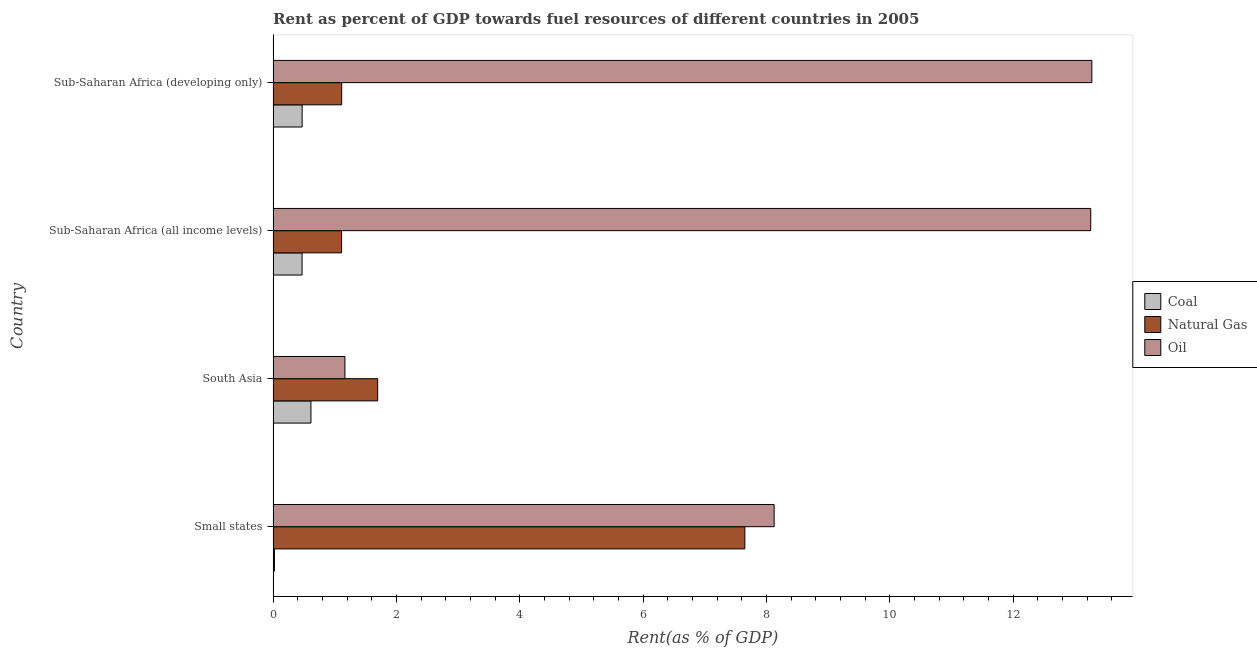How many different coloured bars are there?
Your response must be concise. 3. How many groups of bars are there?
Provide a succinct answer. 4. Are the number of bars per tick equal to the number of legend labels?
Your response must be concise. Yes. Are the number of bars on each tick of the Y-axis equal?
Give a very brief answer. Yes. How many bars are there on the 2nd tick from the top?
Ensure brevity in your answer.  3. How many bars are there on the 4th tick from the bottom?
Keep it short and to the point. 3. What is the label of the 1st group of bars from the top?
Offer a very short reply. Sub-Saharan Africa (developing only). What is the rent towards coal in Small states?
Offer a terse response. 0.02. Across all countries, what is the maximum rent towards coal?
Keep it short and to the point. 0.61. Across all countries, what is the minimum rent towards coal?
Your answer should be compact. 0.02. In which country was the rent towards oil maximum?
Provide a succinct answer. Sub-Saharan Africa (developing only). What is the total rent towards oil in the graph?
Make the answer very short. 35.83. What is the difference between the rent towards natural gas in South Asia and that in Sub-Saharan Africa (developing only)?
Your answer should be very brief. 0.58. What is the difference between the rent towards oil in Small states and the rent towards natural gas in Sub-Saharan Africa (developing only)?
Offer a terse response. 7.01. What is the average rent towards oil per country?
Keep it short and to the point. 8.96. What is the difference between the rent towards oil and rent towards natural gas in Small states?
Provide a short and direct response. 0.47. What is the ratio of the rent towards oil in South Asia to that in Sub-Saharan Africa (all income levels)?
Provide a short and direct response. 0.09. What is the difference between the highest and the second highest rent towards coal?
Provide a short and direct response. 0.14. What is the difference between the highest and the lowest rent towards oil?
Offer a terse response. 12.11. In how many countries, is the rent towards oil greater than the average rent towards oil taken over all countries?
Offer a very short reply. 2. Is the sum of the rent towards natural gas in South Asia and Sub-Saharan Africa (developing only) greater than the maximum rent towards coal across all countries?
Make the answer very short. Yes. What does the 2nd bar from the top in South Asia represents?
Ensure brevity in your answer.  Natural Gas. What does the 1st bar from the bottom in Sub-Saharan Africa (all income levels) represents?
Provide a succinct answer. Coal. Are all the bars in the graph horizontal?
Provide a succinct answer. Yes. How many countries are there in the graph?
Your response must be concise. 4. What is the difference between two consecutive major ticks on the X-axis?
Your answer should be compact. 2. Does the graph contain any zero values?
Provide a succinct answer. No. How are the legend labels stacked?
Your answer should be very brief. Vertical. What is the title of the graph?
Provide a short and direct response. Rent as percent of GDP towards fuel resources of different countries in 2005. Does "Social Protection" appear as one of the legend labels in the graph?
Ensure brevity in your answer.  No. What is the label or title of the X-axis?
Give a very brief answer. Rent(as % of GDP). What is the Rent(as % of GDP) of Coal in Small states?
Offer a very short reply. 0.02. What is the Rent(as % of GDP) of Natural Gas in Small states?
Provide a succinct answer. 7.65. What is the Rent(as % of GDP) in Oil in Small states?
Provide a succinct answer. 8.13. What is the Rent(as % of GDP) in Coal in South Asia?
Give a very brief answer. 0.61. What is the Rent(as % of GDP) of Natural Gas in South Asia?
Provide a succinct answer. 1.7. What is the Rent(as % of GDP) in Oil in South Asia?
Offer a very short reply. 1.16. What is the Rent(as % of GDP) of Coal in Sub-Saharan Africa (all income levels)?
Your answer should be very brief. 0.47. What is the Rent(as % of GDP) in Natural Gas in Sub-Saharan Africa (all income levels)?
Provide a short and direct response. 1.11. What is the Rent(as % of GDP) of Oil in Sub-Saharan Africa (all income levels)?
Your answer should be very brief. 13.26. What is the Rent(as % of GDP) of Coal in Sub-Saharan Africa (developing only)?
Provide a short and direct response. 0.47. What is the Rent(as % of GDP) in Natural Gas in Sub-Saharan Africa (developing only)?
Your response must be concise. 1.11. What is the Rent(as % of GDP) of Oil in Sub-Saharan Africa (developing only)?
Make the answer very short. 13.28. Across all countries, what is the maximum Rent(as % of GDP) in Coal?
Offer a very short reply. 0.61. Across all countries, what is the maximum Rent(as % of GDP) of Natural Gas?
Your answer should be compact. 7.65. Across all countries, what is the maximum Rent(as % of GDP) in Oil?
Your answer should be very brief. 13.28. Across all countries, what is the minimum Rent(as % of GDP) in Coal?
Provide a short and direct response. 0.02. Across all countries, what is the minimum Rent(as % of GDP) in Natural Gas?
Your response must be concise. 1.11. Across all countries, what is the minimum Rent(as % of GDP) of Oil?
Offer a very short reply. 1.16. What is the total Rent(as % of GDP) of Coal in the graph?
Offer a terse response. 1.58. What is the total Rent(as % of GDP) of Natural Gas in the graph?
Provide a short and direct response. 11.57. What is the total Rent(as % of GDP) of Oil in the graph?
Provide a succinct answer. 35.83. What is the difference between the Rent(as % of GDP) in Coal in Small states and that in South Asia?
Provide a short and direct response. -0.59. What is the difference between the Rent(as % of GDP) in Natural Gas in Small states and that in South Asia?
Your answer should be compact. 5.95. What is the difference between the Rent(as % of GDP) in Oil in Small states and that in South Asia?
Make the answer very short. 6.96. What is the difference between the Rent(as % of GDP) of Coal in Small states and that in Sub-Saharan Africa (all income levels)?
Give a very brief answer. -0.45. What is the difference between the Rent(as % of GDP) in Natural Gas in Small states and that in Sub-Saharan Africa (all income levels)?
Make the answer very short. 6.54. What is the difference between the Rent(as % of GDP) of Oil in Small states and that in Sub-Saharan Africa (all income levels)?
Offer a terse response. -5.13. What is the difference between the Rent(as % of GDP) of Coal in Small states and that in Sub-Saharan Africa (developing only)?
Provide a succinct answer. -0.45. What is the difference between the Rent(as % of GDP) in Natural Gas in Small states and that in Sub-Saharan Africa (developing only)?
Give a very brief answer. 6.54. What is the difference between the Rent(as % of GDP) in Oil in Small states and that in Sub-Saharan Africa (developing only)?
Provide a succinct answer. -5.15. What is the difference between the Rent(as % of GDP) of Coal in South Asia and that in Sub-Saharan Africa (all income levels)?
Your response must be concise. 0.14. What is the difference between the Rent(as % of GDP) in Natural Gas in South Asia and that in Sub-Saharan Africa (all income levels)?
Your response must be concise. 0.59. What is the difference between the Rent(as % of GDP) in Oil in South Asia and that in Sub-Saharan Africa (all income levels)?
Your answer should be very brief. -12.1. What is the difference between the Rent(as % of GDP) of Coal in South Asia and that in Sub-Saharan Africa (developing only)?
Keep it short and to the point. 0.14. What is the difference between the Rent(as % of GDP) in Natural Gas in South Asia and that in Sub-Saharan Africa (developing only)?
Offer a very short reply. 0.58. What is the difference between the Rent(as % of GDP) of Oil in South Asia and that in Sub-Saharan Africa (developing only)?
Provide a short and direct response. -12.11. What is the difference between the Rent(as % of GDP) of Coal in Sub-Saharan Africa (all income levels) and that in Sub-Saharan Africa (developing only)?
Provide a succinct answer. -0. What is the difference between the Rent(as % of GDP) in Natural Gas in Sub-Saharan Africa (all income levels) and that in Sub-Saharan Africa (developing only)?
Your answer should be very brief. -0. What is the difference between the Rent(as % of GDP) in Oil in Sub-Saharan Africa (all income levels) and that in Sub-Saharan Africa (developing only)?
Keep it short and to the point. -0.02. What is the difference between the Rent(as % of GDP) of Coal in Small states and the Rent(as % of GDP) of Natural Gas in South Asia?
Keep it short and to the point. -1.67. What is the difference between the Rent(as % of GDP) of Coal in Small states and the Rent(as % of GDP) of Oil in South Asia?
Your answer should be very brief. -1.14. What is the difference between the Rent(as % of GDP) of Natural Gas in Small states and the Rent(as % of GDP) of Oil in South Asia?
Offer a very short reply. 6.49. What is the difference between the Rent(as % of GDP) in Coal in Small states and the Rent(as % of GDP) in Natural Gas in Sub-Saharan Africa (all income levels)?
Provide a short and direct response. -1.09. What is the difference between the Rent(as % of GDP) of Coal in Small states and the Rent(as % of GDP) of Oil in Sub-Saharan Africa (all income levels)?
Provide a short and direct response. -13.24. What is the difference between the Rent(as % of GDP) of Natural Gas in Small states and the Rent(as % of GDP) of Oil in Sub-Saharan Africa (all income levels)?
Your response must be concise. -5.61. What is the difference between the Rent(as % of GDP) of Coal in Small states and the Rent(as % of GDP) of Natural Gas in Sub-Saharan Africa (developing only)?
Your answer should be very brief. -1.09. What is the difference between the Rent(as % of GDP) in Coal in Small states and the Rent(as % of GDP) in Oil in Sub-Saharan Africa (developing only)?
Offer a terse response. -13.26. What is the difference between the Rent(as % of GDP) in Natural Gas in Small states and the Rent(as % of GDP) in Oil in Sub-Saharan Africa (developing only)?
Offer a terse response. -5.63. What is the difference between the Rent(as % of GDP) of Coal in South Asia and the Rent(as % of GDP) of Natural Gas in Sub-Saharan Africa (all income levels)?
Give a very brief answer. -0.5. What is the difference between the Rent(as % of GDP) of Coal in South Asia and the Rent(as % of GDP) of Oil in Sub-Saharan Africa (all income levels)?
Give a very brief answer. -12.65. What is the difference between the Rent(as % of GDP) in Natural Gas in South Asia and the Rent(as % of GDP) in Oil in Sub-Saharan Africa (all income levels)?
Your response must be concise. -11.56. What is the difference between the Rent(as % of GDP) in Coal in South Asia and the Rent(as % of GDP) in Natural Gas in Sub-Saharan Africa (developing only)?
Provide a succinct answer. -0.5. What is the difference between the Rent(as % of GDP) in Coal in South Asia and the Rent(as % of GDP) in Oil in Sub-Saharan Africa (developing only)?
Make the answer very short. -12.66. What is the difference between the Rent(as % of GDP) in Natural Gas in South Asia and the Rent(as % of GDP) in Oil in Sub-Saharan Africa (developing only)?
Offer a terse response. -11.58. What is the difference between the Rent(as % of GDP) of Coal in Sub-Saharan Africa (all income levels) and the Rent(as % of GDP) of Natural Gas in Sub-Saharan Africa (developing only)?
Offer a terse response. -0.64. What is the difference between the Rent(as % of GDP) of Coal in Sub-Saharan Africa (all income levels) and the Rent(as % of GDP) of Oil in Sub-Saharan Africa (developing only)?
Give a very brief answer. -12.81. What is the difference between the Rent(as % of GDP) in Natural Gas in Sub-Saharan Africa (all income levels) and the Rent(as % of GDP) in Oil in Sub-Saharan Africa (developing only)?
Offer a terse response. -12.17. What is the average Rent(as % of GDP) in Coal per country?
Make the answer very short. 0.39. What is the average Rent(as % of GDP) in Natural Gas per country?
Your response must be concise. 2.89. What is the average Rent(as % of GDP) of Oil per country?
Your answer should be very brief. 8.96. What is the difference between the Rent(as % of GDP) in Coal and Rent(as % of GDP) in Natural Gas in Small states?
Ensure brevity in your answer.  -7.63. What is the difference between the Rent(as % of GDP) of Coal and Rent(as % of GDP) of Oil in Small states?
Offer a very short reply. -8.1. What is the difference between the Rent(as % of GDP) in Natural Gas and Rent(as % of GDP) in Oil in Small states?
Provide a short and direct response. -0.47. What is the difference between the Rent(as % of GDP) of Coal and Rent(as % of GDP) of Natural Gas in South Asia?
Your answer should be very brief. -1.08. What is the difference between the Rent(as % of GDP) in Coal and Rent(as % of GDP) in Oil in South Asia?
Provide a succinct answer. -0.55. What is the difference between the Rent(as % of GDP) in Natural Gas and Rent(as % of GDP) in Oil in South Asia?
Your answer should be compact. 0.53. What is the difference between the Rent(as % of GDP) of Coal and Rent(as % of GDP) of Natural Gas in Sub-Saharan Africa (all income levels)?
Offer a very short reply. -0.64. What is the difference between the Rent(as % of GDP) in Coal and Rent(as % of GDP) in Oil in Sub-Saharan Africa (all income levels)?
Provide a short and direct response. -12.79. What is the difference between the Rent(as % of GDP) in Natural Gas and Rent(as % of GDP) in Oil in Sub-Saharan Africa (all income levels)?
Keep it short and to the point. -12.15. What is the difference between the Rent(as % of GDP) of Coal and Rent(as % of GDP) of Natural Gas in Sub-Saharan Africa (developing only)?
Offer a very short reply. -0.64. What is the difference between the Rent(as % of GDP) of Coal and Rent(as % of GDP) of Oil in Sub-Saharan Africa (developing only)?
Ensure brevity in your answer.  -12.81. What is the difference between the Rent(as % of GDP) of Natural Gas and Rent(as % of GDP) of Oil in Sub-Saharan Africa (developing only)?
Your answer should be compact. -12.17. What is the ratio of the Rent(as % of GDP) in Coal in Small states to that in South Asia?
Give a very brief answer. 0.04. What is the ratio of the Rent(as % of GDP) in Natural Gas in Small states to that in South Asia?
Your answer should be very brief. 4.51. What is the ratio of the Rent(as % of GDP) of Oil in Small states to that in South Asia?
Keep it short and to the point. 6.98. What is the ratio of the Rent(as % of GDP) of Coal in Small states to that in Sub-Saharan Africa (all income levels)?
Offer a very short reply. 0.05. What is the ratio of the Rent(as % of GDP) of Natural Gas in Small states to that in Sub-Saharan Africa (all income levels)?
Ensure brevity in your answer.  6.89. What is the ratio of the Rent(as % of GDP) of Oil in Small states to that in Sub-Saharan Africa (all income levels)?
Offer a very short reply. 0.61. What is the ratio of the Rent(as % of GDP) of Coal in Small states to that in Sub-Saharan Africa (developing only)?
Make the answer very short. 0.05. What is the ratio of the Rent(as % of GDP) of Natural Gas in Small states to that in Sub-Saharan Africa (developing only)?
Your answer should be very brief. 6.88. What is the ratio of the Rent(as % of GDP) in Oil in Small states to that in Sub-Saharan Africa (developing only)?
Keep it short and to the point. 0.61. What is the ratio of the Rent(as % of GDP) of Coal in South Asia to that in Sub-Saharan Africa (all income levels)?
Keep it short and to the point. 1.31. What is the ratio of the Rent(as % of GDP) in Natural Gas in South Asia to that in Sub-Saharan Africa (all income levels)?
Your answer should be very brief. 1.53. What is the ratio of the Rent(as % of GDP) in Oil in South Asia to that in Sub-Saharan Africa (all income levels)?
Keep it short and to the point. 0.09. What is the ratio of the Rent(as % of GDP) of Coal in South Asia to that in Sub-Saharan Africa (developing only)?
Give a very brief answer. 1.3. What is the ratio of the Rent(as % of GDP) in Natural Gas in South Asia to that in Sub-Saharan Africa (developing only)?
Your answer should be compact. 1.52. What is the ratio of the Rent(as % of GDP) in Oil in South Asia to that in Sub-Saharan Africa (developing only)?
Give a very brief answer. 0.09. What is the ratio of the Rent(as % of GDP) in Oil in Sub-Saharan Africa (all income levels) to that in Sub-Saharan Africa (developing only)?
Offer a terse response. 1. What is the difference between the highest and the second highest Rent(as % of GDP) in Coal?
Offer a terse response. 0.14. What is the difference between the highest and the second highest Rent(as % of GDP) of Natural Gas?
Make the answer very short. 5.95. What is the difference between the highest and the second highest Rent(as % of GDP) of Oil?
Provide a succinct answer. 0.02. What is the difference between the highest and the lowest Rent(as % of GDP) of Coal?
Your response must be concise. 0.59. What is the difference between the highest and the lowest Rent(as % of GDP) of Natural Gas?
Ensure brevity in your answer.  6.54. What is the difference between the highest and the lowest Rent(as % of GDP) in Oil?
Give a very brief answer. 12.11. 